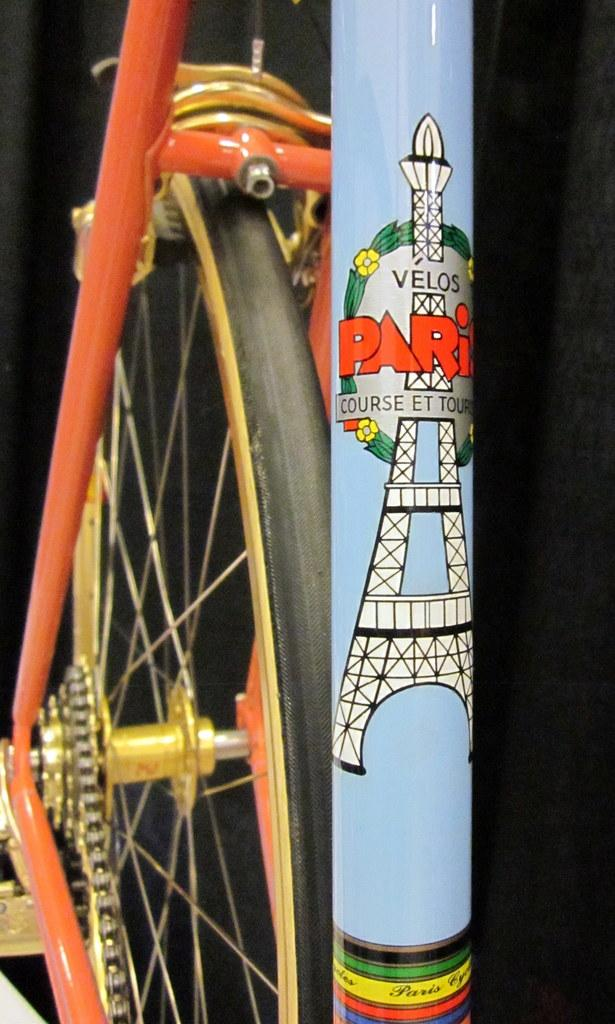What is the main object in the center of the image? There is a wheel, rods, a chain, and a pole in the center of the image. Can you describe the arrangement of these objects? The wheel, rods, chain, and pole are all located in the center of the image. What is the color of the background in the image? The background of the image is dark. What type of news can be heard coming from the radio in the image? There is no radio present in the image, so it's not possible to determine what news might be heard. What type of oatmeal is being prepared in the image? There is no oatmeal or cooking activity present in the image. 